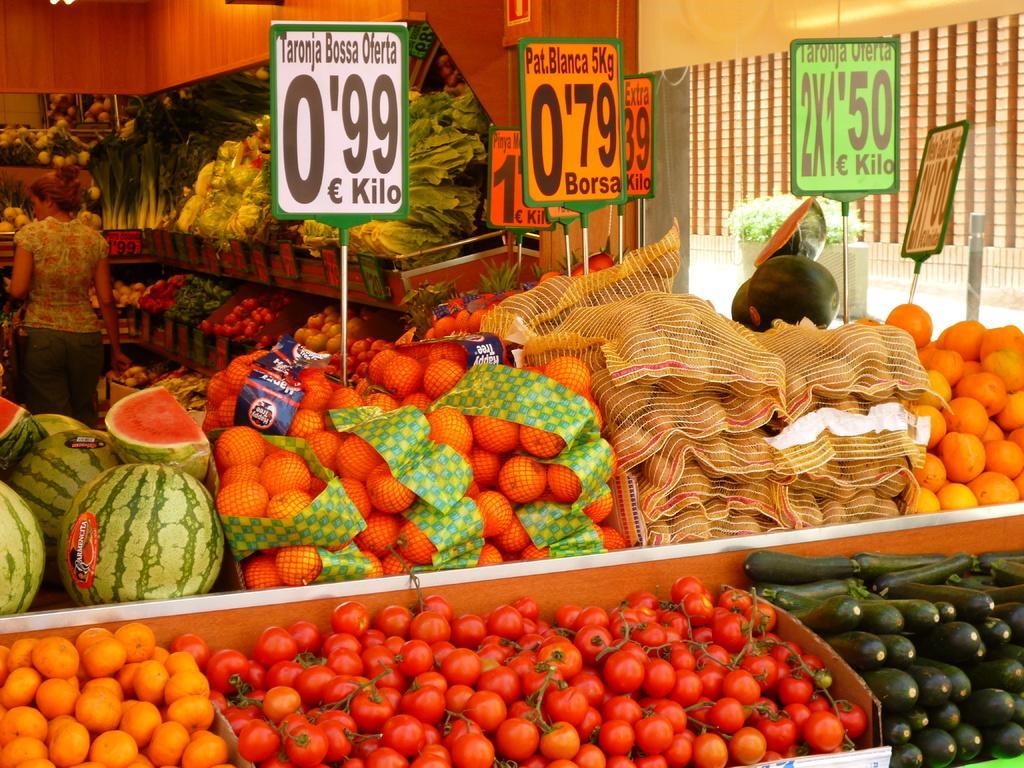In one or two sentences, can you explain what this image depicts? In this picture I can see fruits on the table. Here I can see boards on which something written on them. In the background I can see a woman is standing. I can also see vegetables and fruits. In the background I can see wooden object and a wall. 